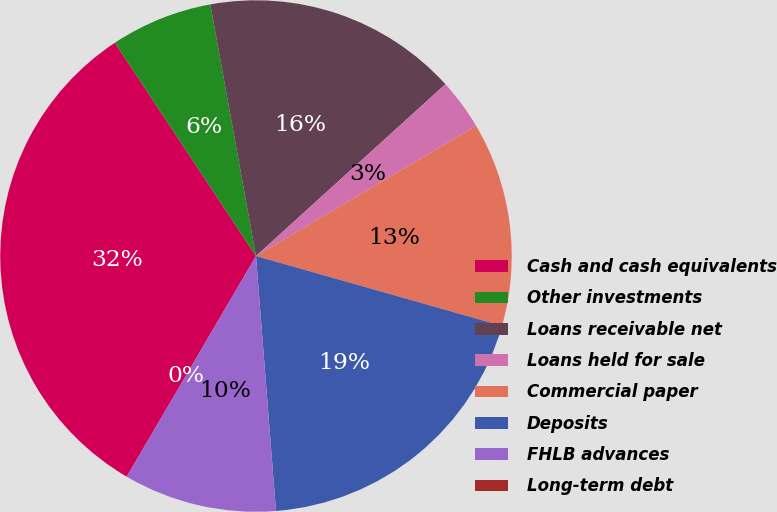<chart> <loc_0><loc_0><loc_500><loc_500><pie_chart><fcel>Cash and cash equivalents<fcel>Other investments<fcel>Loans receivable net<fcel>Loans held for sale<fcel>Commercial paper<fcel>Deposits<fcel>FHLB advances<fcel>Long-term debt<nl><fcel>32.26%<fcel>6.45%<fcel>16.13%<fcel>3.23%<fcel>12.9%<fcel>19.35%<fcel>9.68%<fcel>0.0%<nl></chart> 